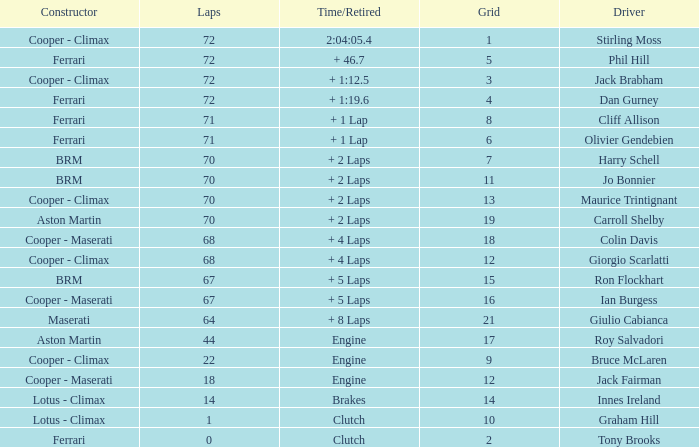What is the time/retired for phil hill with over 67 laps and a grad smaller than 18? + 46.7. 